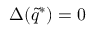<formula> <loc_0><loc_0><loc_500><loc_500>\Delta ( \tilde { q } ^ { * } ) = 0</formula> 